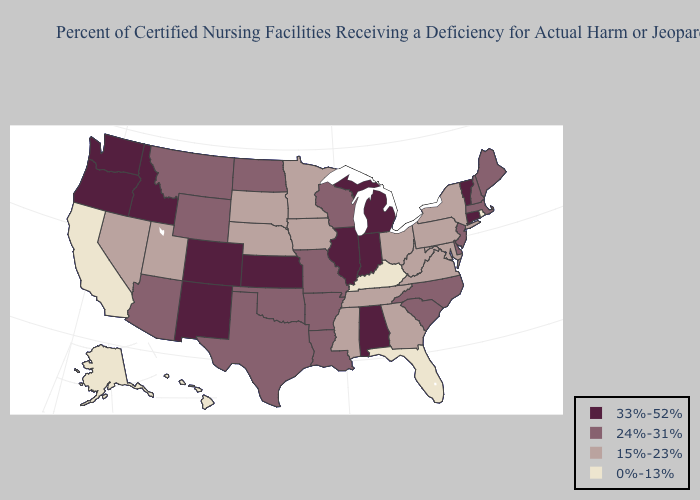What is the highest value in the South ?
Short answer required. 33%-52%. Name the states that have a value in the range 15%-23%?
Quick response, please. Georgia, Iowa, Maryland, Minnesota, Mississippi, Nebraska, Nevada, New York, Ohio, Pennsylvania, South Dakota, Tennessee, Utah, Virginia, West Virginia. Name the states that have a value in the range 24%-31%?
Short answer required. Arizona, Arkansas, Delaware, Louisiana, Maine, Massachusetts, Missouri, Montana, New Hampshire, New Jersey, North Carolina, North Dakota, Oklahoma, South Carolina, Texas, Wisconsin, Wyoming. Among the states that border Wyoming , does Idaho have the lowest value?
Keep it brief. No. Among the states that border Delaware , does Maryland have the highest value?
Give a very brief answer. No. What is the highest value in the MidWest ?
Write a very short answer. 33%-52%. What is the value of Washington?
Be succinct. 33%-52%. What is the value of New Jersey?
Answer briefly. 24%-31%. What is the value of Kansas?
Quick response, please. 33%-52%. Among the states that border Indiana , does Illinois have the highest value?
Give a very brief answer. Yes. Does Kentucky have the lowest value in the USA?
Answer briefly. Yes. What is the highest value in states that border Minnesota?
Be succinct. 24%-31%. What is the lowest value in states that border Utah?
Keep it brief. 15%-23%. Which states have the lowest value in the West?
Keep it brief. Alaska, California, Hawaii. 